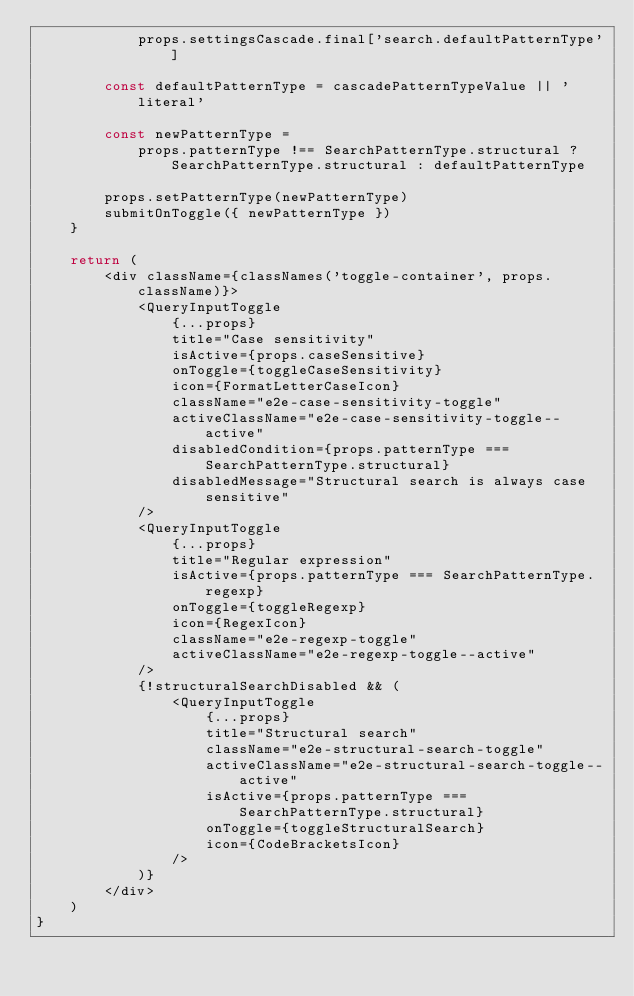Convert code to text. <code><loc_0><loc_0><loc_500><loc_500><_TypeScript_>            props.settingsCascade.final['search.defaultPatternType']

        const defaultPatternType = cascadePatternTypeValue || 'literal'

        const newPatternType =
            props.patternType !== SearchPatternType.structural ? SearchPatternType.structural : defaultPatternType

        props.setPatternType(newPatternType)
        submitOnToggle({ newPatternType })
    }

    return (
        <div className={classNames('toggle-container', props.className)}>
            <QueryInputToggle
                {...props}
                title="Case sensitivity"
                isActive={props.caseSensitive}
                onToggle={toggleCaseSensitivity}
                icon={FormatLetterCaseIcon}
                className="e2e-case-sensitivity-toggle"
                activeClassName="e2e-case-sensitivity-toggle--active"
                disabledCondition={props.patternType === SearchPatternType.structural}
                disabledMessage="Structural search is always case sensitive"
            />
            <QueryInputToggle
                {...props}
                title="Regular expression"
                isActive={props.patternType === SearchPatternType.regexp}
                onToggle={toggleRegexp}
                icon={RegexIcon}
                className="e2e-regexp-toggle"
                activeClassName="e2e-regexp-toggle--active"
            />
            {!structuralSearchDisabled && (
                <QueryInputToggle
                    {...props}
                    title="Structural search"
                    className="e2e-structural-search-toggle"
                    activeClassName="e2e-structural-search-toggle--active"
                    isActive={props.patternType === SearchPatternType.structural}
                    onToggle={toggleStructuralSearch}
                    icon={CodeBracketsIcon}
                />
            )}
        </div>
    )
}
</code> 